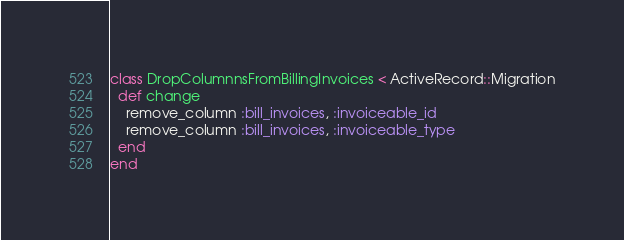Convert code to text. <code><loc_0><loc_0><loc_500><loc_500><_Ruby_>class DropColumnnsFromBillingInvoices < ActiveRecord::Migration
  def change
    remove_column :bill_invoices, :invoiceable_id
    remove_column :bill_invoices, :invoiceable_type
  end
end
</code> 